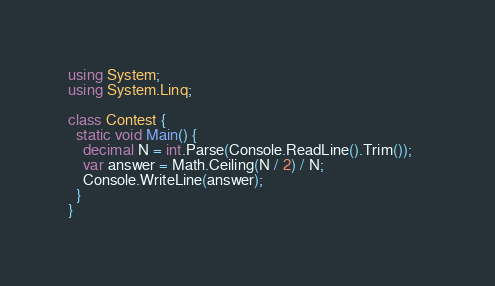Convert code to text. <code><loc_0><loc_0><loc_500><loc_500><_C#_>using System;
using System.Linq;

class Contest {
  static void Main() {
    decimal N = int.Parse(Console.ReadLine().Trim());    
    var answer = Math.Ceiling(N / 2) / N;
    Console.WriteLine(answer);
  }
}</code> 